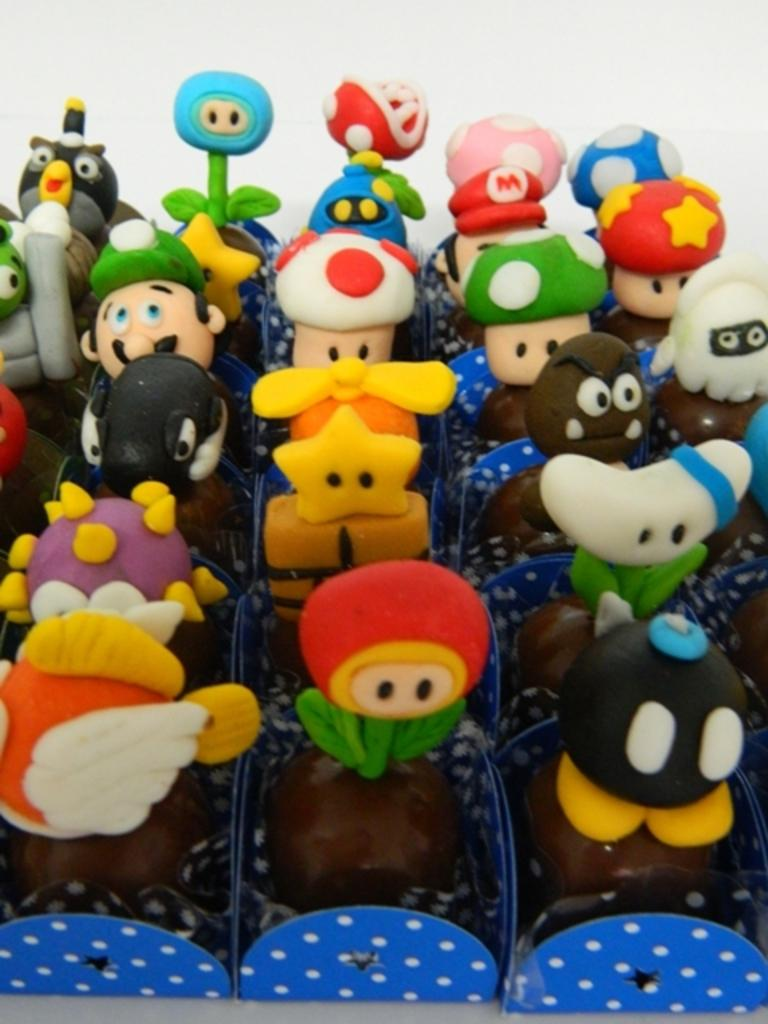What type of food is visible in the image? The food is in boxes, but the specific type of food cannot be determined from the provided facts. How are the food items arranged in the image? The food is in boxes, which suggests they are organized or contained in some way. What is the surface at the bottom of the image? The surface at the bottom of the image could be a table, countertop, or other flat surface, but the specific material or color cannot be determined from the provided facts. What color is the background of the image? The background of the image is white. How many trees are visible in the image? There are no trees visible in the image; the background is white. What type of heart is shown beating in the image? There is no heart present in the image; it features food in boxes with a white background. 